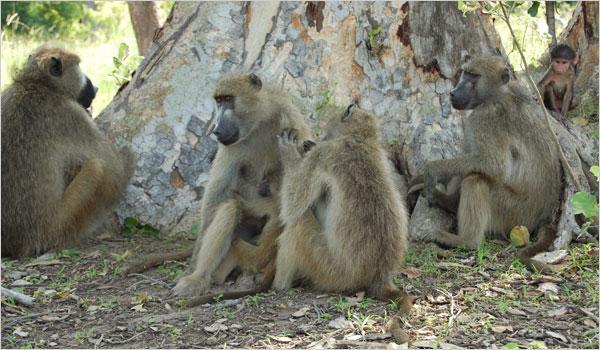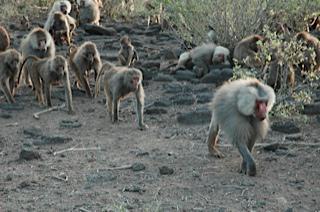The first image is the image on the left, the second image is the image on the right. For the images displayed, is the sentence "The pink rear ends of several primates are visible." factually correct? Answer yes or no. No. The first image is the image on the left, the second image is the image on the right. Examine the images to the left and right. Is the description "An image shows multiple rear-facing baboons with bulbous pink rears." accurate? Answer yes or no. No. 